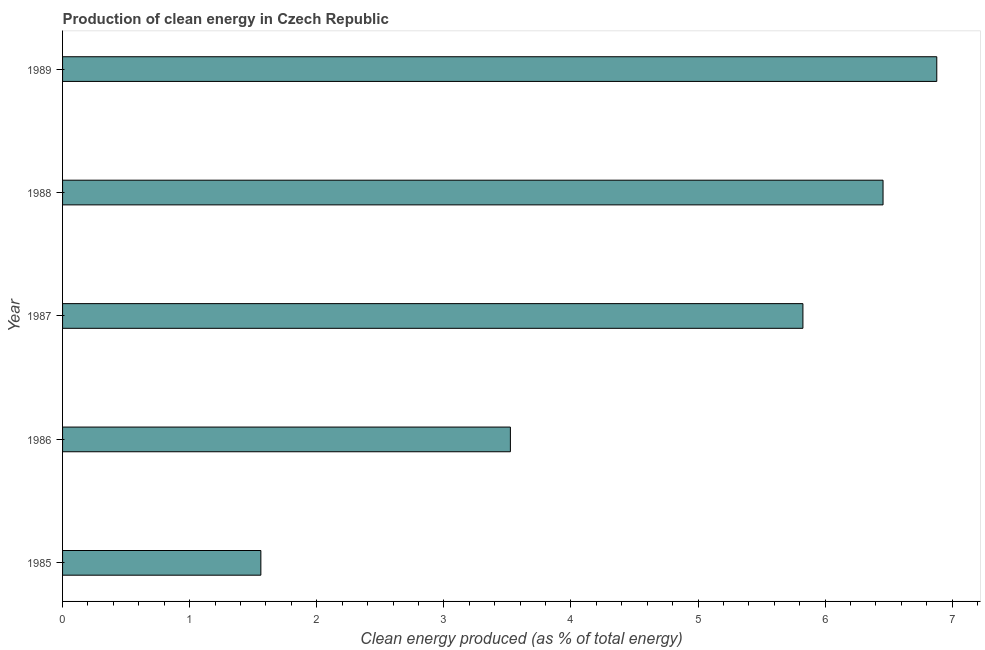What is the title of the graph?
Give a very brief answer. Production of clean energy in Czech Republic. What is the label or title of the X-axis?
Provide a short and direct response. Clean energy produced (as % of total energy). What is the production of clean energy in 1988?
Offer a terse response. 6.46. Across all years, what is the maximum production of clean energy?
Offer a terse response. 6.88. Across all years, what is the minimum production of clean energy?
Ensure brevity in your answer.  1.56. What is the sum of the production of clean energy?
Ensure brevity in your answer.  24.24. What is the difference between the production of clean energy in 1987 and 1989?
Provide a succinct answer. -1.05. What is the average production of clean energy per year?
Ensure brevity in your answer.  4.85. What is the median production of clean energy?
Provide a succinct answer. 5.83. In how many years, is the production of clean energy greater than 6.8 %?
Your answer should be very brief. 1. Do a majority of the years between 1985 and 1989 (inclusive) have production of clean energy greater than 5.2 %?
Keep it short and to the point. Yes. What is the ratio of the production of clean energy in 1985 to that in 1988?
Keep it short and to the point. 0.24. What is the difference between the highest and the second highest production of clean energy?
Offer a very short reply. 0.42. What is the difference between the highest and the lowest production of clean energy?
Your answer should be compact. 5.32. In how many years, is the production of clean energy greater than the average production of clean energy taken over all years?
Make the answer very short. 3. How many bars are there?
Keep it short and to the point. 5. Are the values on the major ticks of X-axis written in scientific E-notation?
Ensure brevity in your answer.  No. What is the Clean energy produced (as % of total energy) in 1985?
Make the answer very short. 1.56. What is the Clean energy produced (as % of total energy) in 1986?
Your answer should be compact. 3.52. What is the Clean energy produced (as % of total energy) of 1987?
Offer a very short reply. 5.83. What is the Clean energy produced (as % of total energy) in 1988?
Keep it short and to the point. 6.46. What is the Clean energy produced (as % of total energy) of 1989?
Make the answer very short. 6.88. What is the difference between the Clean energy produced (as % of total energy) in 1985 and 1986?
Make the answer very short. -1.96. What is the difference between the Clean energy produced (as % of total energy) in 1985 and 1987?
Make the answer very short. -4.27. What is the difference between the Clean energy produced (as % of total energy) in 1985 and 1988?
Make the answer very short. -4.9. What is the difference between the Clean energy produced (as % of total energy) in 1985 and 1989?
Provide a succinct answer. -5.32. What is the difference between the Clean energy produced (as % of total energy) in 1986 and 1987?
Your answer should be very brief. -2.3. What is the difference between the Clean energy produced (as % of total energy) in 1986 and 1988?
Your answer should be very brief. -2.93. What is the difference between the Clean energy produced (as % of total energy) in 1986 and 1989?
Give a very brief answer. -3.35. What is the difference between the Clean energy produced (as % of total energy) in 1987 and 1988?
Keep it short and to the point. -0.63. What is the difference between the Clean energy produced (as % of total energy) in 1987 and 1989?
Give a very brief answer. -1.05. What is the difference between the Clean energy produced (as % of total energy) in 1988 and 1989?
Offer a terse response. -0.42. What is the ratio of the Clean energy produced (as % of total energy) in 1985 to that in 1986?
Provide a succinct answer. 0.44. What is the ratio of the Clean energy produced (as % of total energy) in 1985 to that in 1987?
Your response must be concise. 0.27. What is the ratio of the Clean energy produced (as % of total energy) in 1985 to that in 1988?
Your response must be concise. 0.24. What is the ratio of the Clean energy produced (as % of total energy) in 1985 to that in 1989?
Your answer should be compact. 0.23. What is the ratio of the Clean energy produced (as % of total energy) in 1986 to that in 1987?
Keep it short and to the point. 0.6. What is the ratio of the Clean energy produced (as % of total energy) in 1986 to that in 1988?
Make the answer very short. 0.55. What is the ratio of the Clean energy produced (as % of total energy) in 1986 to that in 1989?
Keep it short and to the point. 0.51. What is the ratio of the Clean energy produced (as % of total energy) in 1987 to that in 1988?
Offer a very short reply. 0.9. What is the ratio of the Clean energy produced (as % of total energy) in 1987 to that in 1989?
Ensure brevity in your answer.  0.85. What is the ratio of the Clean energy produced (as % of total energy) in 1988 to that in 1989?
Provide a succinct answer. 0.94. 